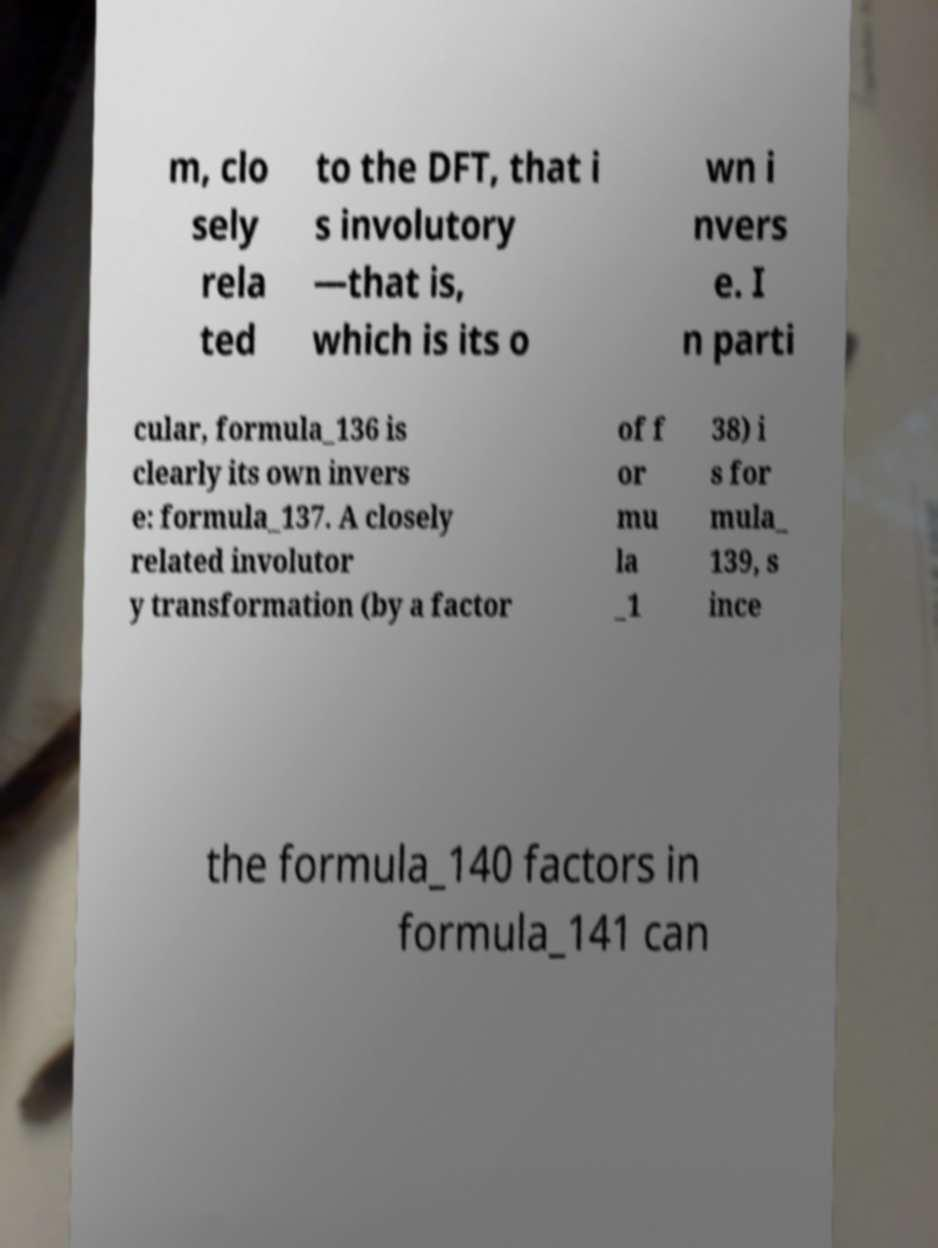Please identify and transcribe the text found in this image. m, clo sely rela ted to the DFT, that i s involutory —that is, which is its o wn i nvers e. I n parti cular, formula_136 is clearly its own invers e: formula_137. A closely related involutor y transformation (by a factor of f or mu la _1 38) i s for mula_ 139, s ince the formula_140 factors in formula_141 can 